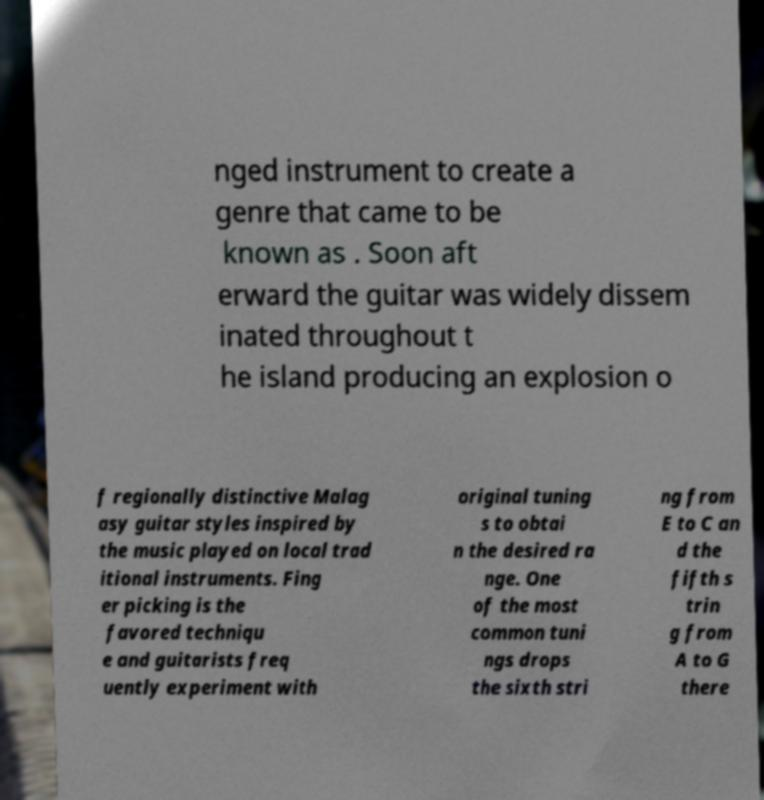I need the written content from this picture converted into text. Can you do that? nged instrument to create a genre that came to be known as . Soon aft erward the guitar was widely dissem inated throughout t he island producing an explosion o f regionally distinctive Malag asy guitar styles inspired by the music played on local trad itional instruments. Fing er picking is the favored techniqu e and guitarists freq uently experiment with original tuning s to obtai n the desired ra nge. One of the most common tuni ngs drops the sixth stri ng from E to C an d the fifth s trin g from A to G there 